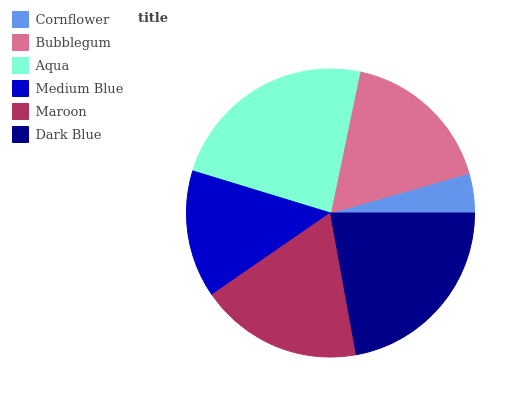Is Cornflower the minimum?
Answer yes or no. Yes. Is Aqua the maximum?
Answer yes or no. Yes. Is Bubblegum the minimum?
Answer yes or no. No. Is Bubblegum the maximum?
Answer yes or no. No. Is Bubblegum greater than Cornflower?
Answer yes or no. Yes. Is Cornflower less than Bubblegum?
Answer yes or no. Yes. Is Cornflower greater than Bubblegum?
Answer yes or no. No. Is Bubblegum less than Cornflower?
Answer yes or no. No. Is Maroon the high median?
Answer yes or no. Yes. Is Bubblegum the low median?
Answer yes or no. Yes. Is Dark Blue the high median?
Answer yes or no. No. Is Dark Blue the low median?
Answer yes or no. No. 